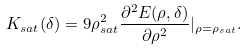<formula> <loc_0><loc_0><loc_500><loc_500>K _ { s a t } ( \delta ) = 9 \rho _ { s a t } ^ { 2 } \frac { \partial ^ { 2 } E ( \rho , \delta ) } { \partial \rho ^ { 2 } } | _ { \rho = \rho _ { s a t } } .</formula> 